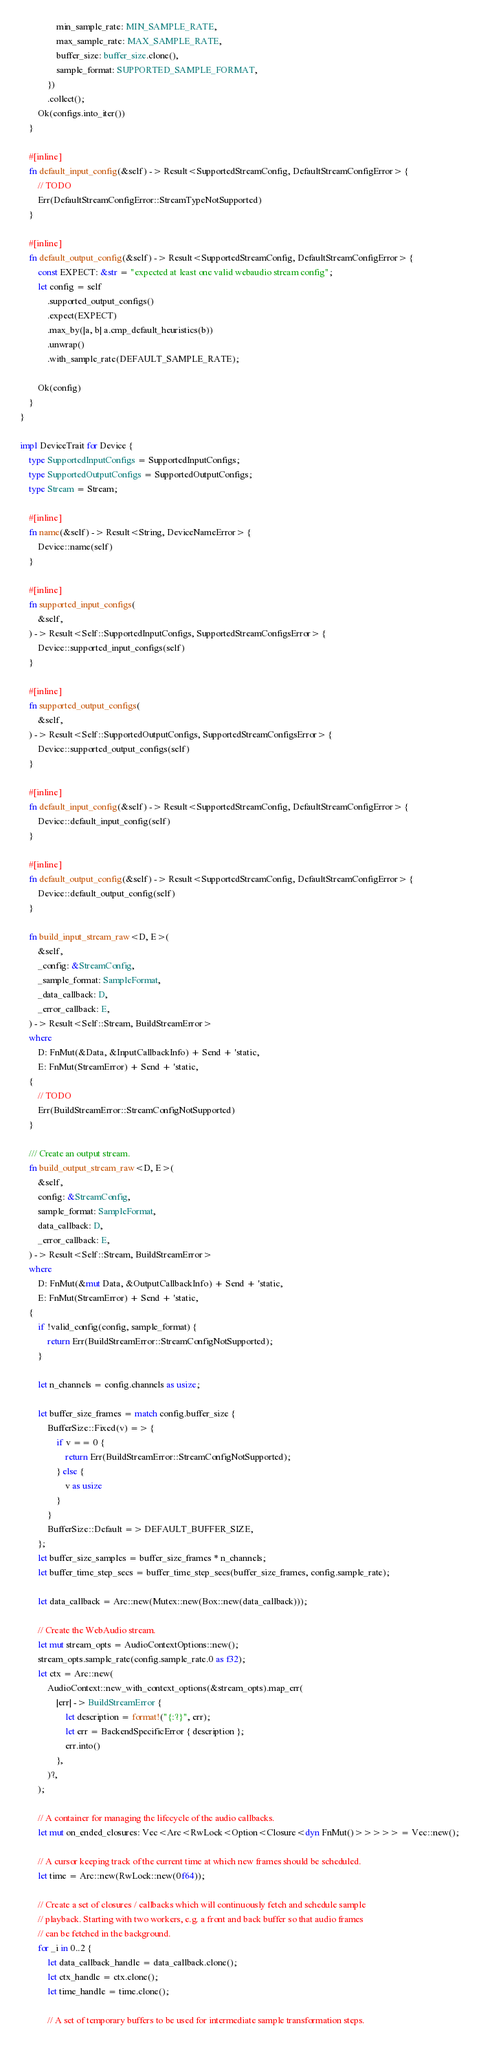Convert code to text. <code><loc_0><loc_0><loc_500><loc_500><_Rust_>                min_sample_rate: MIN_SAMPLE_RATE,
                max_sample_rate: MAX_SAMPLE_RATE,
                buffer_size: buffer_size.clone(),
                sample_format: SUPPORTED_SAMPLE_FORMAT,
            })
            .collect();
        Ok(configs.into_iter())
    }

    #[inline]
    fn default_input_config(&self) -> Result<SupportedStreamConfig, DefaultStreamConfigError> {
        // TODO
        Err(DefaultStreamConfigError::StreamTypeNotSupported)
    }

    #[inline]
    fn default_output_config(&self) -> Result<SupportedStreamConfig, DefaultStreamConfigError> {
        const EXPECT: &str = "expected at least one valid webaudio stream config";
        let config = self
            .supported_output_configs()
            .expect(EXPECT)
            .max_by(|a, b| a.cmp_default_heuristics(b))
            .unwrap()
            .with_sample_rate(DEFAULT_SAMPLE_RATE);

        Ok(config)
    }
}

impl DeviceTrait for Device {
    type SupportedInputConfigs = SupportedInputConfigs;
    type SupportedOutputConfigs = SupportedOutputConfigs;
    type Stream = Stream;

    #[inline]
    fn name(&self) -> Result<String, DeviceNameError> {
        Device::name(self)
    }

    #[inline]
    fn supported_input_configs(
        &self,
    ) -> Result<Self::SupportedInputConfigs, SupportedStreamConfigsError> {
        Device::supported_input_configs(self)
    }

    #[inline]
    fn supported_output_configs(
        &self,
    ) -> Result<Self::SupportedOutputConfigs, SupportedStreamConfigsError> {
        Device::supported_output_configs(self)
    }

    #[inline]
    fn default_input_config(&self) -> Result<SupportedStreamConfig, DefaultStreamConfigError> {
        Device::default_input_config(self)
    }

    #[inline]
    fn default_output_config(&self) -> Result<SupportedStreamConfig, DefaultStreamConfigError> {
        Device::default_output_config(self)
    }

    fn build_input_stream_raw<D, E>(
        &self,
        _config: &StreamConfig,
        _sample_format: SampleFormat,
        _data_callback: D,
        _error_callback: E,
    ) -> Result<Self::Stream, BuildStreamError>
    where
        D: FnMut(&Data, &InputCallbackInfo) + Send + 'static,
        E: FnMut(StreamError) + Send + 'static,
    {
        // TODO
        Err(BuildStreamError::StreamConfigNotSupported)
    }

    /// Create an output stream.
    fn build_output_stream_raw<D, E>(
        &self,
        config: &StreamConfig,
        sample_format: SampleFormat,
        data_callback: D,
        _error_callback: E,
    ) -> Result<Self::Stream, BuildStreamError>
    where
        D: FnMut(&mut Data, &OutputCallbackInfo) + Send + 'static,
        E: FnMut(StreamError) + Send + 'static,
    {
        if !valid_config(config, sample_format) {
            return Err(BuildStreamError::StreamConfigNotSupported);
        }

        let n_channels = config.channels as usize;

        let buffer_size_frames = match config.buffer_size {
            BufferSize::Fixed(v) => {
                if v == 0 {
                    return Err(BuildStreamError::StreamConfigNotSupported);
                } else {
                    v as usize
                }
            }
            BufferSize::Default => DEFAULT_BUFFER_SIZE,
        };
        let buffer_size_samples = buffer_size_frames * n_channels;
        let buffer_time_step_secs = buffer_time_step_secs(buffer_size_frames, config.sample_rate);

        let data_callback = Arc::new(Mutex::new(Box::new(data_callback)));

        // Create the WebAudio stream.
        let mut stream_opts = AudioContextOptions::new();
        stream_opts.sample_rate(config.sample_rate.0 as f32);
        let ctx = Arc::new(
            AudioContext::new_with_context_options(&stream_opts).map_err(
                |err| -> BuildStreamError {
                    let description = format!("{:?}", err);
                    let err = BackendSpecificError { description };
                    err.into()
                },
            )?,
        );

        // A container for managing the lifecycle of the audio callbacks.
        let mut on_ended_closures: Vec<Arc<RwLock<Option<Closure<dyn FnMut()>>>>> = Vec::new();

        // A cursor keeping track of the current time at which new frames should be scheduled.
        let time = Arc::new(RwLock::new(0f64));

        // Create a set of closures / callbacks which will continuously fetch and schedule sample
        // playback. Starting with two workers, e.g. a front and back buffer so that audio frames
        // can be fetched in the background.
        for _i in 0..2 {
            let data_callback_handle = data_callback.clone();
            let ctx_handle = ctx.clone();
            let time_handle = time.clone();

            // A set of temporary buffers to be used for intermediate sample transformation steps.</code> 